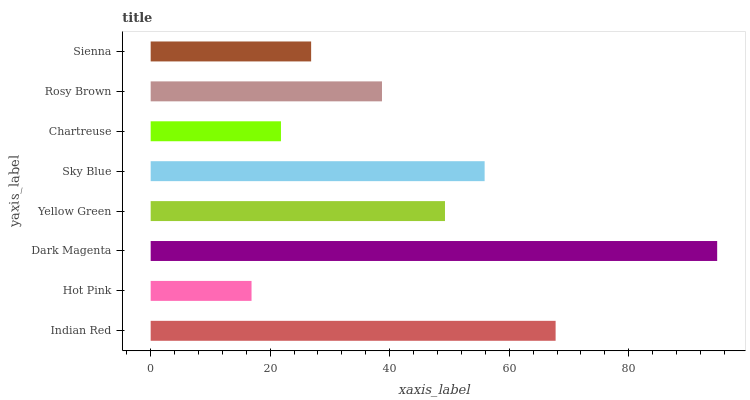Is Hot Pink the minimum?
Answer yes or no. Yes. Is Dark Magenta the maximum?
Answer yes or no. Yes. Is Dark Magenta the minimum?
Answer yes or no. No. Is Hot Pink the maximum?
Answer yes or no. No. Is Dark Magenta greater than Hot Pink?
Answer yes or no. Yes. Is Hot Pink less than Dark Magenta?
Answer yes or no. Yes. Is Hot Pink greater than Dark Magenta?
Answer yes or no. No. Is Dark Magenta less than Hot Pink?
Answer yes or no. No. Is Yellow Green the high median?
Answer yes or no. Yes. Is Rosy Brown the low median?
Answer yes or no. Yes. Is Hot Pink the high median?
Answer yes or no. No. Is Indian Red the low median?
Answer yes or no. No. 